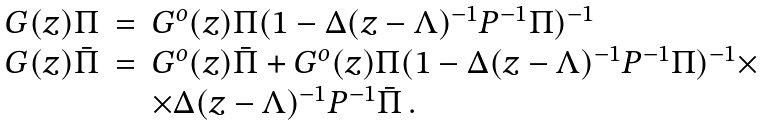<formula> <loc_0><loc_0><loc_500><loc_500>\begin{array} { l l l } G ( z ) \Pi & = & G ^ { o } ( z ) \Pi ( 1 - \Delta ( z - \Lambda ) ^ { - 1 } P ^ { - 1 } \Pi ) ^ { - 1 } \\ G ( z ) \bar { \Pi } & = & G ^ { o } ( z ) \bar { \Pi } + G ^ { o } ( z ) \Pi ( 1 - \Delta ( z - \Lambda ) ^ { - 1 } P ^ { - 1 } \Pi ) ^ { - 1 } \times \\ & & \times \Delta ( z - \Lambda ) ^ { - 1 } P ^ { - 1 } \bar { \Pi } \, . \end{array}</formula> 